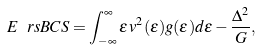<formula> <loc_0><loc_0><loc_500><loc_500>E \ r s { B C S } = \int _ { - \infty } ^ { \infty } \epsilon \, v ^ { 2 } ( \epsilon ) g ( \epsilon ) d \epsilon - \frac { \Delta ^ { 2 } } { G } ,</formula> 